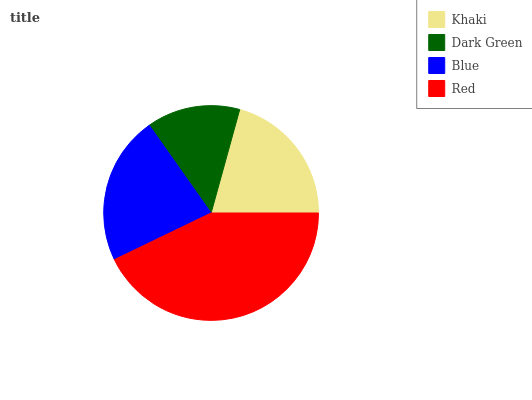Is Dark Green the minimum?
Answer yes or no. Yes. Is Red the maximum?
Answer yes or no. Yes. Is Blue the minimum?
Answer yes or no. No. Is Blue the maximum?
Answer yes or no. No. Is Blue greater than Dark Green?
Answer yes or no. Yes. Is Dark Green less than Blue?
Answer yes or no. Yes. Is Dark Green greater than Blue?
Answer yes or no. No. Is Blue less than Dark Green?
Answer yes or no. No. Is Blue the high median?
Answer yes or no. Yes. Is Khaki the low median?
Answer yes or no. Yes. Is Khaki the high median?
Answer yes or no. No. Is Red the low median?
Answer yes or no. No. 